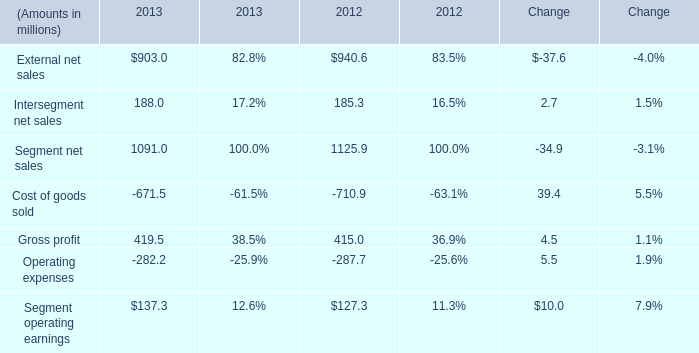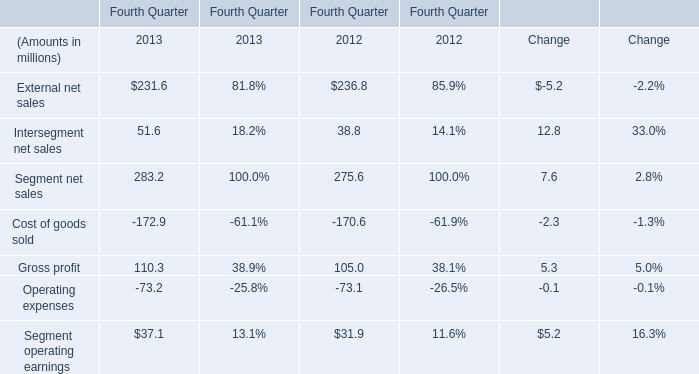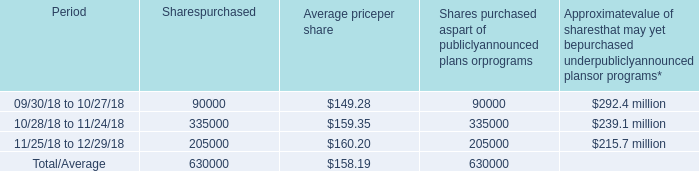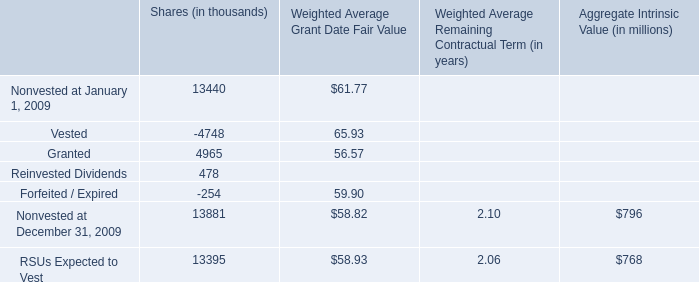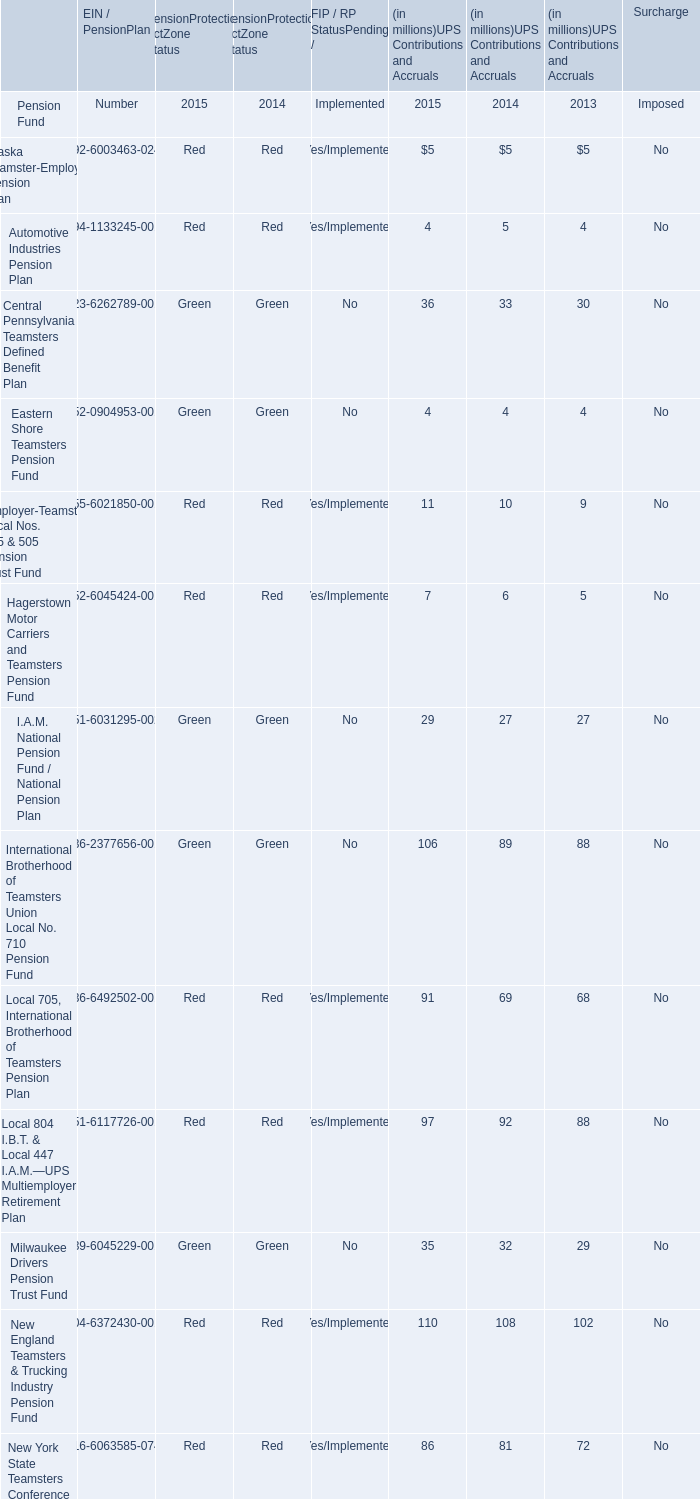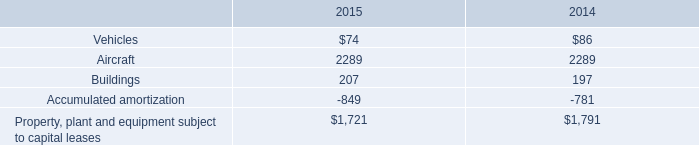what is the percentage change in vehicles under capital lease between 2014 and 2015? 
Computations: ((74 - 86) / 86)
Answer: -0.13953. 